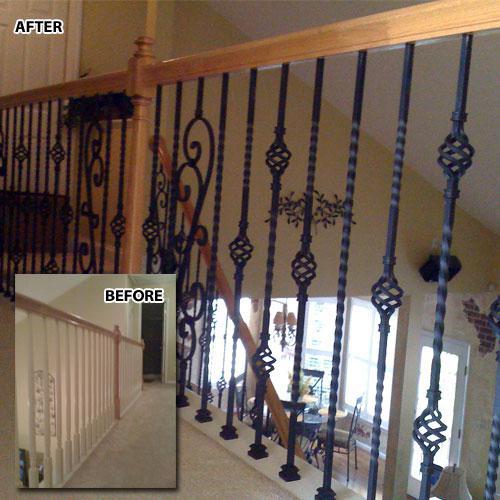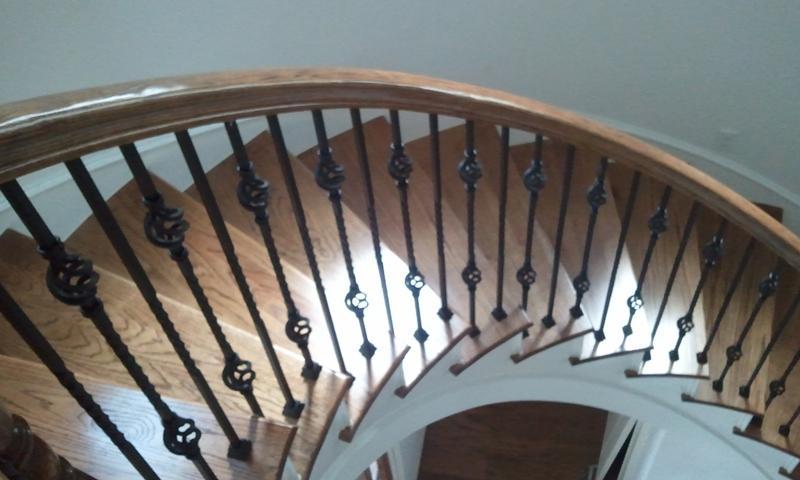The first image is the image on the left, the second image is the image on the right. Assess this claim about the two images: "In at least one image there is  a set of stairs point left forward with the bottom step longer than the rest.". Correct or not? Answer yes or no. No. The first image is the image on the left, the second image is the image on the right. For the images displayed, is the sentence "The right image shows a curving staircase with brown steps and white baseboards, a curving brown rail, and black wrought iron bars." factually correct? Answer yes or no. Yes. 